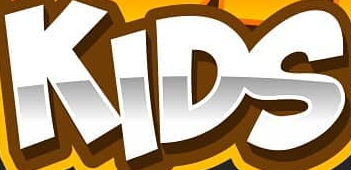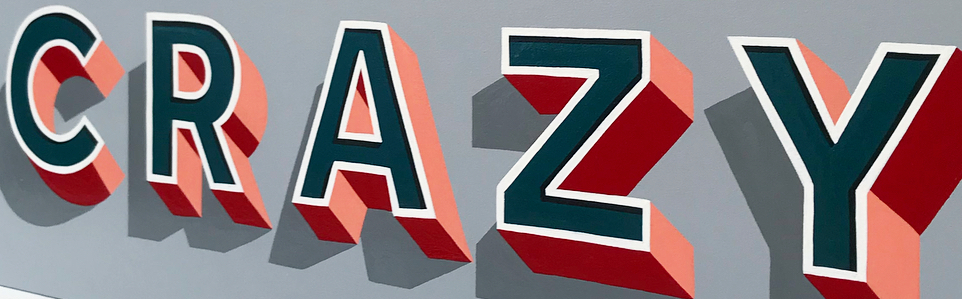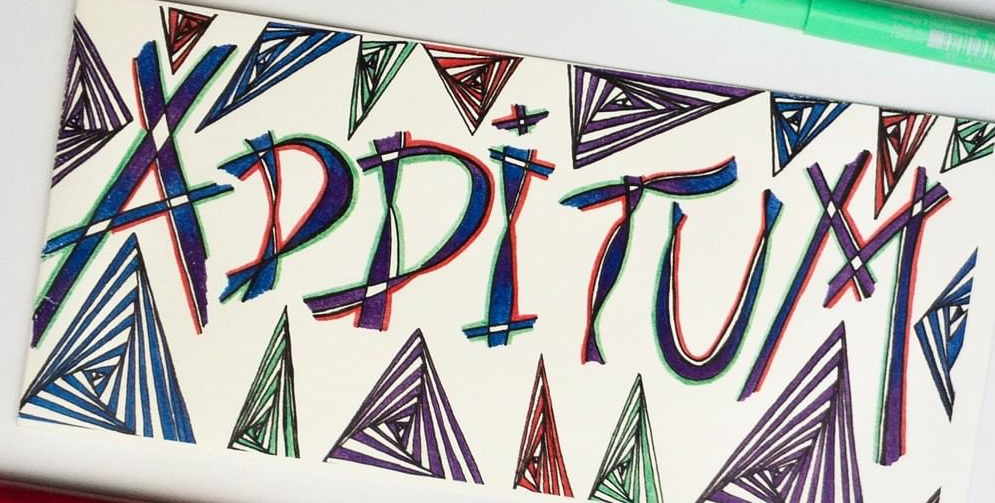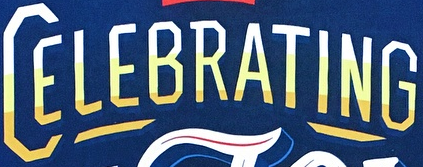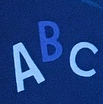What text is displayed in these images sequentially, separated by a semicolon? KIDS; CRAZY; ADDITUM; CELEBRATING; ABC 